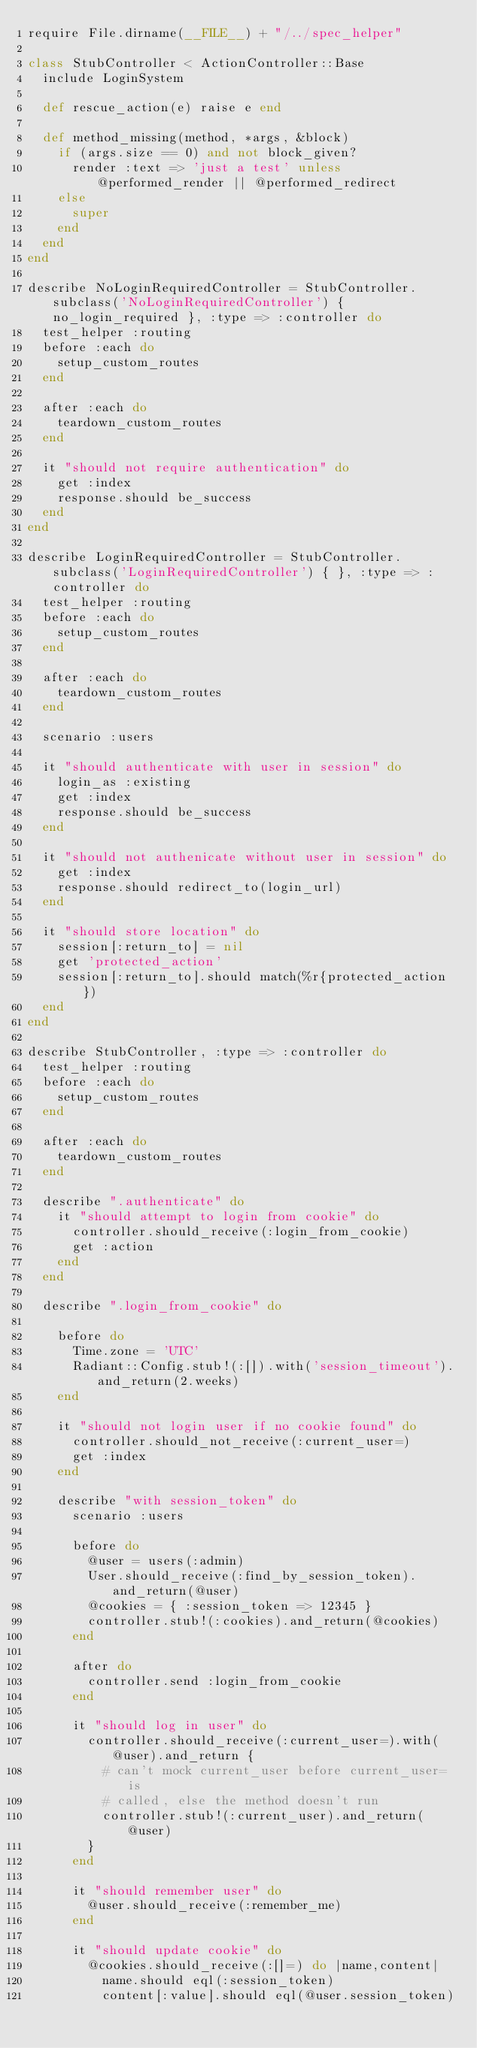<code> <loc_0><loc_0><loc_500><loc_500><_Ruby_>require File.dirname(__FILE__) + "/../spec_helper"

class StubController < ActionController::Base
  include LoginSystem
  
  def rescue_action(e) raise e end
  
  def method_missing(method, *args, &block)
    if (args.size == 0) and not block_given?
      render :text => 'just a test' unless @performed_render || @performed_redirect
    else
      super
    end
  end
end

describe NoLoginRequiredController = StubController.subclass('NoLoginRequiredController') { no_login_required }, :type => :controller do
  test_helper :routing
  before :each do
    setup_custom_routes
  end
  
  after :each do
    teardown_custom_routes
  end
  
  it "should not require authentication" do
    get :index
    response.should be_success
  end
end

describe LoginRequiredController = StubController.subclass('LoginRequiredController') { }, :type => :controller do
  test_helper :routing
  before :each do
    setup_custom_routes
  end
  
  after :each do
    teardown_custom_routes
  end
  
  scenario :users

  it "should authenticate with user in session" do
    login_as :existing
    get :index
    response.should be_success
  end
  
  it "should not authenicate without user in session" do
    get :index
    response.should redirect_to(login_url)
  end
  
  it "should store location" do
    session[:return_to] = nil
    get 'protected_action'
    session[:return_to].should match(%r{protected_action})
  end
end

describe StubController, :type => :controller do
  test_helper :routing
  before :each do
    setup_custom_routes
  end
  
  after :each do
    teardown_custom_routes
  end
  
  describe ".authenticate" do
    it "should attempt to login from cookie" do
      controller.should_receive(:login_from_cookie)
      get :action
    end
  end

  describe ".login_from_cookie" do

    before do
      Time.zone = 'UTC'
      Radiant::Config.stub!(:[]).with('session_timeout').and_return(2.weeks)
    end

    it "should not login user if no cookie found" do
      controller.should_not_receive(:current_user=)
      get :index
    end

    describe "with session_token" do
      scenario :users

      before do
        @user = users(:admin)
        User.should_receive(:find_by_session_token).and_return(@user)
        @cookies = { :session_token => 12345 }
        controller.stub!(:cookies).and_return(@cookies)
      end

      after do
        controller.send :login_from_cookie
      end

      it "should log in user" do
        controller.should_receive(:current_user=).with(@user).and_return {
          # can't mock current_user before current_user= is
          # called, else the method doesn't run
          controller.stub!(:current_user).and_return(@user)
        }
      end

      it "should remember user" do
        @user.should_receive(:remember_me)
      end

      it "should update cookie" do
        @cookies.should_receive(:[]=) do |name,content|
          name.should eql(:session_token)
          content[:value].should eql(@user.session_token)</code> 